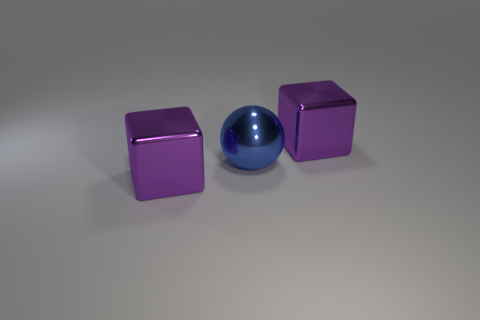Is there anything else that has the same shape as the blue metal object?
Provide a succinct answer. No. What shape is the blue metallic thing right of the purple metallic object that is to the left of the big object that is right of the large blue metal ball?
Your response must be concise. Sphere. What size is the blue ball?
Your answer should be compact. Large. What number of large purple cubes are made of the same material as the blue ball?
Give a very brief answer. 2. There is a big ball; is it the same color as the thing that is to the right of the large ball?
Keep it short and to the point. No. What is the color of the large block to the left of the purple metal cube that is behind the blue thing?
Provide a succinct answer. Purple. Is there another big blue rubber thing of the same shape as the large blue thing?
Keep it short and to the point. No. What is the shape of the blue thing?
Provide a short and direct response. Sphere. There is a purple object behind the big purple block that is on the left side of the blue metal sphere; how many big shiny blocks are behind it?
Your answer should be compact. 0. Is there any other thing that is the same color as the metal ball?
Provide a short and direct response. No. 